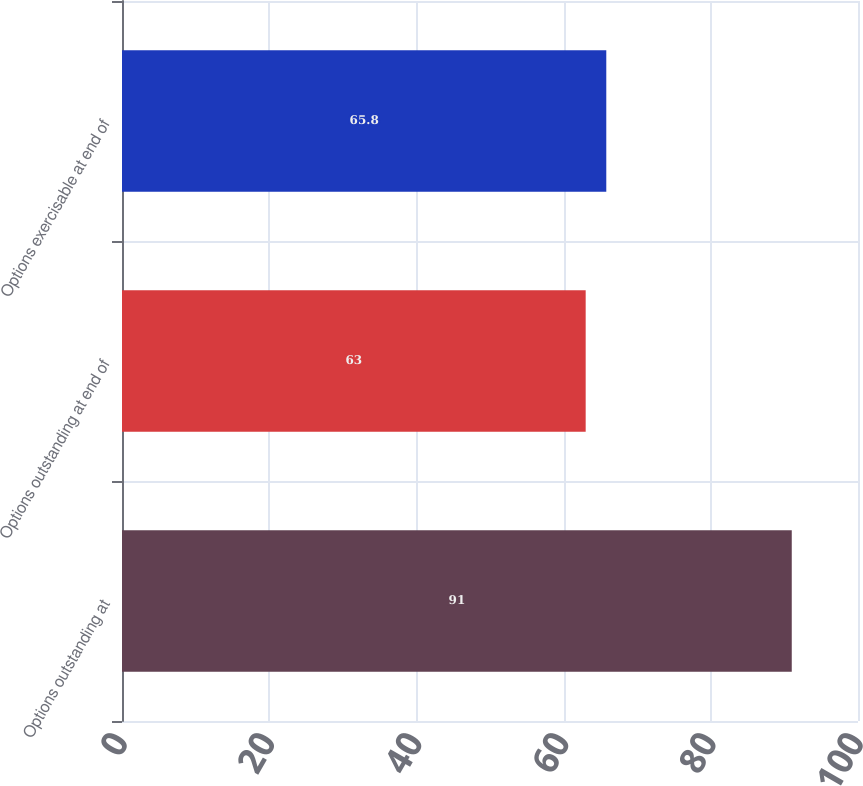Convert chart to OTSL. <chart><loc_0><loc_0><loc_500><loc_500><bar_chart><fcel>Options outstanding at<fcel>Options outstanding at end of<fcel>Options exercisable at end of<nl><fcel>91<fcel>63<fcel>65.8<nl></chart> 